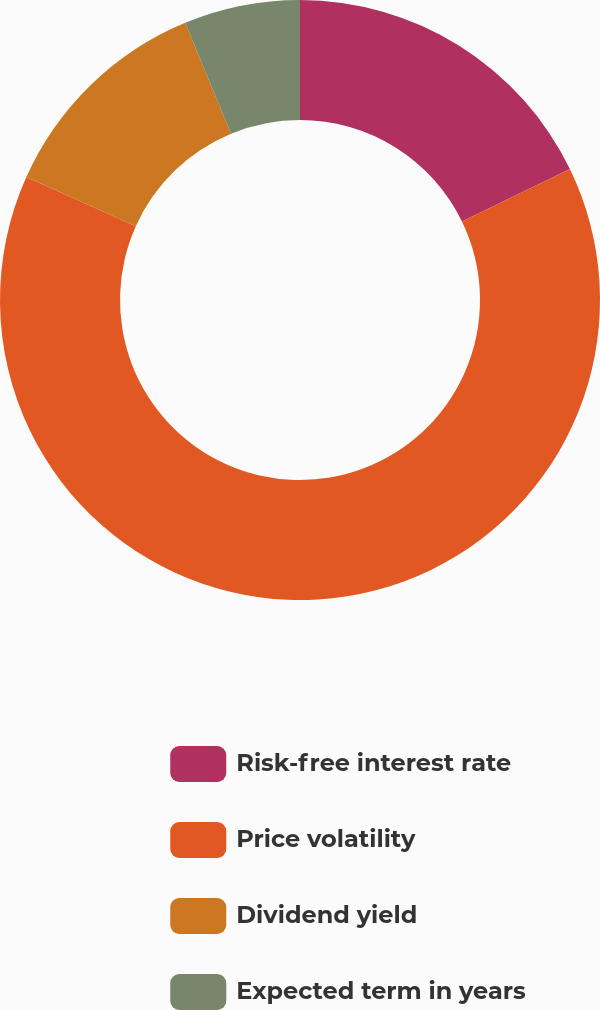<chart> <loc_0><loc_0><loc_500><loc_500><pie_chart><fcel>Risk-free interest rate<fcel>Price volatility<fcel>Dividend yield<fcel>Expected term in years<nl><fcel>17.81%<fcel>63.92%<fcel>12.03%<fcel>6.25%<nl></chart> 